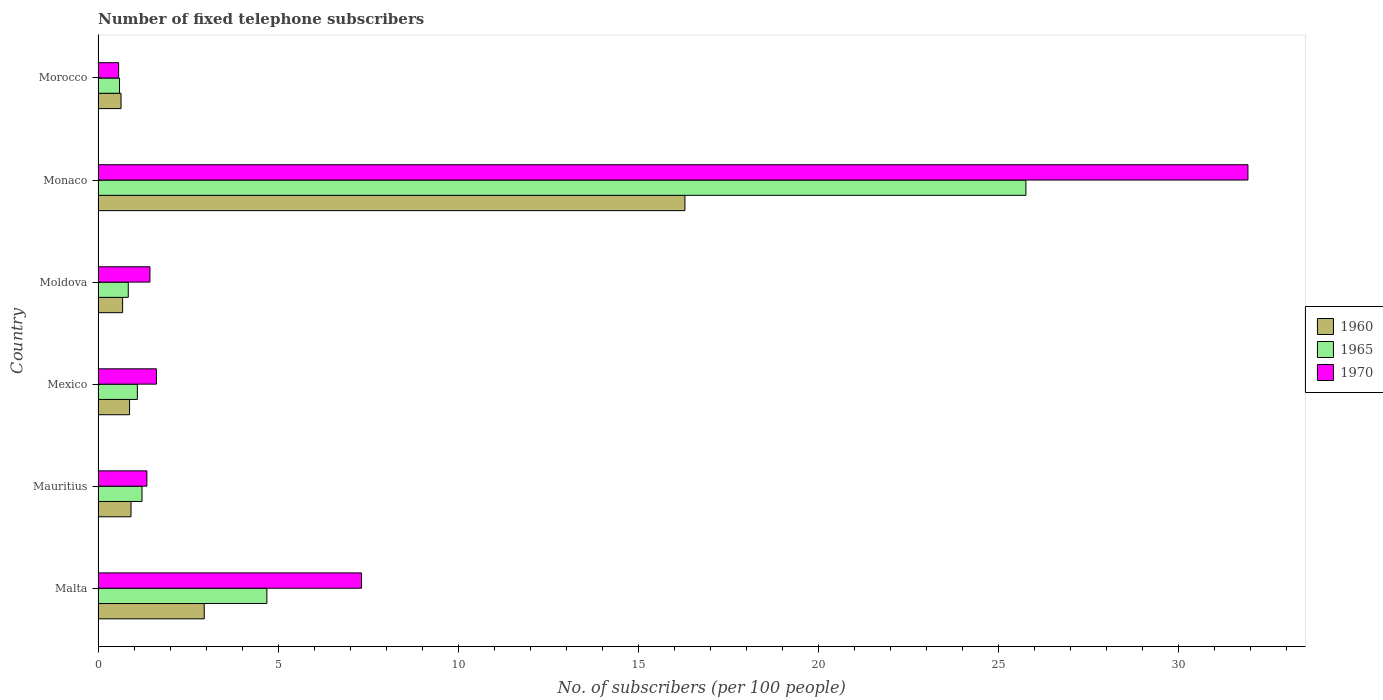How many different coloured bars are there?
Ensure brevity in your answer.  3. Are the number of bars per tick equal to the number of legend labels?
Keep it short and to the point. Yes. Are the number of bars on each tick of the Y-axis equal?
Provide a succinct answer. Yes. How many bars are there on the 4th tick from the bottom?
Your answer should be very brief. 3. What is the label of the 2nd group of bars from the top?
Offer a terse response. Monaco. In how many cases, is the number of bars for a given country not equal to the number of legend labels?
Offer a very short reply. 0. What is the number of fixed telephone subscribers in 1960 in Mauritius?
Offer a very short reply. 0.92. Across all countries, what is the maximum number of fixed telephone subscribers in 1960?
Provide a succinct answer. 16.3. Across all countries, what is the minimum number of fixed telephone subscribers in 1965?
Provide a short and direct response. 0.6. In which country was the number of fixed telephone subscribers in 1965 maximum?
Offer a terse response. Monaco. In which country was the number of fixed telephone subscribers in 1965 minimum?
Provide a succinct answer. Morocco. What is the total number of fixed telephone subscribers in 1970 in the graph?
Your response must be concise. 44.24. What is the difference between the number of fixed telephone subscribers in 1970 in Mauritius and that in Monaco?
Keep it short and to the point. -30.58. What is the difference between the number of fixed telephone subscribers in 1970 in Mauritius and the number of fixed telephone subscribers in 1965 in Morocco?
Keep it short and to the point. 0.76. What is the average number of fixed telephone subscribers in 1970 per country?
Your answer should be compact. 7.37. What is the difference between the number of fixed telephone subscribers in 1960 and number of fixed telephone subscribers in 1970 in Mauritius?
Provide a short and direct response. -0.44. What is the ratio of the number of fixed telephone subscribers in 1960 in Mauritius to that in Moldova?
Your answer should be compact. 1.34. What is the difference between the highest and the second highest number of fixed telephone subscribers in 1970?
Give a very brief answer. 24.62. What is the difference between the highest and the lowest number of fixed telephone subscribers in 1960?
Offer a terse response. 15.66. What does the 2nd bar from the top in Monaco represents?
Provide a succinct answer. 1965. How many bars are there?
Your answer should be compact. 18. Are all the bars in the graph horizontal?
Ensure brevity in your answer.  Yes. How many countries are there in the graph?
Offer a terse response. 6. Does the graph contain any zero values?
Your answer should be compact. No. How many legend labels are there?
Make the answer very short. 3. How are the legend labels stacked?
Your response must be concise. Vertical. What is the title of the graph?
Offer a terse response. Number of fixed telephone subscribers. Does "1984" appear as one of the legend labels in the graph?
Offer a very short reply. No. What is the label or title of the X-axis?
Ensure brevity in your answer.  No. of subscribers (per 100 people). What is the No. of subscribers (per 100 people) in 1960 in Malta?
Give a very brief answer. 2.95. What is the No. of subscribers (per 100 people) in 1965 in Malta?
Offer a terse response. 4.69. What is the No. of subscribers (per 100 people) of 1970 in Malta?
Give a very brief answer. 7.32. What is the No. of subscribers (per 100 people) in 1960 in Mauritius?
Provide a succinct answer. 0.92. What is the No. of subscribers (per 100 people) of 1965 in Mauritius?
Your answer should be very brief. 1.22. What is the No. of subscribers (per 100 people) of 1970 in Mauritius?
Ensure brevity in your answer.  1.36. What is the No. of subscribers (per 100 people) in 1960 in Mexico?
Offer a very short reply. 0.88. What is the No. of subscribers (per 100 people) in 1965 in Mexico?
Keep it short and to the point. 1.09. What is the No. of subscribers (per 100 people) in 1970 in Mexico?
Ensure brevity in your answer.  1.62. What is the No. of subscribers (per 100 people) of 1960 in Moldova?
Offer a very short reply. 0.68. What is the No. of subscribers (per 100 people) in 1965 in Moldova?
Ensure brevity in your answer.  0.84. What is the No. of subscribers (per 100 people) in 1970 in Moldova?
Give a very brief answer. 1.44. What is the No. of subscribers (per 100 people) of 1960 in Monaco?
Give a very brief answer. 16.3. What is the No. of subscribers (per 100 people) in 1965 in Monaco?
Make the answer very short. 25.77. What is the No. of subscribers (per 100 people) of 1970 in Monaco?
Provide a short and direct response. 31.94. What is the No. of subscribers (per 100 people) in 1960 in Morocco?
Give a very brief answer. 0.64. What is the No. of subscribers (per 100 people) of 1965 in Morocco?
Keep it short and to the point. 0.6. What is the No. of subscribers (per 100 people) in 1970 in Morocco?
Your response must be concise. 0.57. Across all countries, what is the maximum No. of subscribers (per 100 people) in 1960?
Provide a short and direct response. 16.3. Across all countries, what is the maximum No. of subscribers (per 100 people) of 1965?
Your answer should be compact. 25.77. Across all countries, what is the maximum No. of subscribers (per 100 people) of 1970?
Provide a short and direct response. 31.94. Across all countries, what is the minimum No. of subscribers (per 100 people) in 1960?
Your response must be concise. 0.64. Across all countries, what is the minimum No. of subscribers (per 100 people) in 1965?
Provide a succinct answer. 0.6. Across all countries, what is the minimum No. of subscribers (per 100 people) in 1970?
Provide a short and direct response. 0.57. What is the total No. of subscribers (per 100 people) in 1960 in the graph?
Keep it short and to the point. 22.36. What is the total No. of subscribers (per 100 people) of 1965 in the graph?
Provide a succinct answer. 34.21. What is the total No. of subscribers (per 100 people) of 1970 in the graph?
Provide a succinct answer. 44.24. What is the difference between the No. of subscribers (per 100 people) of 1960 in Malta and that in Mauritius?
Make the answer very short. 2.03. What is the difference between the No. of subscribers (per 100 people) of 1965 in Malta and that in Mauritius?
Keep it short and to the point. 3.47. What is the difference between the No. of subscribers (per 100 people) of 1970 in Malta and that in Mauritius?
Make the answer very short. 5.96. What is the difference between the No. of subscribers (per 100 people) in 1960 in Malta and that in Mexico?
Provide a short and direct response. 2.07. What is the difference between the No. of subscribers (per 100 people) of 1965 in Malta and that in Mexico?
Keep it short and to the point. 3.6. What is the difference between the No. of subscribers (per 100 people) of 1970 in Malta and that in Mexico?
Your answer should be very brief. 5.7. What is the difference between the No. of subscribers (per 100 people) of 1960 in Malta and that in Moldova?
Keep it short and to the point. 2.27. What is the difference between the No. of subscribers (per 100 people) in 1965 in Malta and that in Moldova?
Provide a short and direct response. 3.85. What is the difference between the No. of subscribers (per 100 people) in 1970 in Malta and that in Moldova?
Your answer should be very brief. 5.88. What is the difference between the No. of subscribers (per 100 people) of 1960 in Malta and that in Monaco?
Provide a short and direct response. -13.35. What is the difference between the No. of subscribers (per 100 people) of 1965 in Malta and that in Monaco?
Offer a very short reply. -21.08. What is the difference between the No. of subscribers (per 100 people) of 1970 in Malta and that in Monaco?
Keep it short and to the point. -24.62. What is the difference between the No. of subscribers (per 100 people) in 1960 in Malta and that in Morocco?
Make the answer very short. 2.31. What is the difference between the No. of subscribers (per 100 people) in 1965 in Malta and that in Morocco?
Your answer should be very brief. 4.09. What is the difference between the No. of subscribers (per 100 people) of 1970 in Malta and that in Morocco?
Your answer should be compact. 6.75. What is the difference between the No. of subscribers (per 100 people) of 1960 in Mauritius and that in Mexico?
Your answer should be compact. 0.04. What is the difference between the No. of subscribers (per 100 people) in 1965 in Mauritius and that in Mexico?
Your response must be concise. 0.13. What is the difference between the No. of subscribers (per 100 people) of 1970 in Mauritius and that in Mexico?
Ensure brevity in your answer.  -0.26. What is the difference between the No. of subscribers (per 100 people) of 1960 in Mauritius and that in Moldova?
Your answer should be compact. 0.23. What is the difference between the No. of subscribers (per 100 people) of 1965 in Mauritius and that in Moldova?
Provide a succinct answer. 0.38. What is the difference between the No. of subscribers (per 100 people) of 1970 in Mauritius and that in Moldova?
Provide a succinct answer. -0.08. What is the difference between the No. of subscribers (per 100 people) of 1960 in Mauritius and that in Monaco?
Your answer should be very brief. -15.38. What is the difference between the No. of subscribers (per 100 people) in 1965 in Mauritius and that in Monaco?
Ensure brevity in your answer.  -24.55. What is the difference between the No. of subscribers (per 100 people) in 1970 in Mauritius and that in Monaco?
Your answer should be compact. -30.58. What is the difference between the No. of subscribers (per 100 people) of 1960 in Mauritius and that in Morocco?
Give a very brief answer. 0.28. What is the difference between the No. of subscribers (per 100 people) in 1965 in Mauritius and that in Morocco?
Your response must be concise. 0.63. What is the difference between the No. of subscribers (per 100 people) in 1970 in Mauritius and that in Morocco?
Keep it short and to the point. 0.78. What is the difference between the No. of subscribers (per 100 people) in 1960 in Mexico and that in Moldova?
Your answer should be compact. 0.19. What is the difference between the No. of subscribers (per 100 people) in 1965 in Mexico and that in Moldova?
Provide a succinct answer. 0.25. What is the difference between the No. of subscribers (per 100 people) of 1970 in Mexico and that in Moldova?
Give a very brief answer. 0.18. What is the difference between the No. of subscribers (per 100 people) in 1960 in Mexico and that in Monaco?
Your answer should be very brief. -15.42. What is the difference between the No. of subscribers (per 100 people) in 1965 in Mexico and that in Monaco?
Provide a short and direct response. -24.68. What is the difference between the No. of subscribers (per 100 people) in 1970 in Mexico and that in Monaco?
Your response must be concise. -30.32. What is the difference between the No. of subscribers (per 100 people) in 1960 in Mexico and that in Morocco?
Your answer should be compact. 0.24. What is the difference between the No. of subscribers (per 100 people) of 1965 in Mexico and that in Morocco?
Offer a very short reply. 0.5. What is the difference between the No. of subscribers (per 100 people) of 1970 in Mexico and that in Morocco?
Your response must be concise. 1.05. What is the difference between the No. of subscribers (per 100 people) of 1960 in Moldova and that in Monaco?
Offer a terse response. -15.62. What is the difference between the No. of subscribers (per 100 people) in 1965 in Moldova and that in Monaco?
Offer a very short reply. -24.93. What is the difference between the No. of subscribers (per 100 people) in 1970 in Moldova and that in Monaco?
Your answer should be compact. -30.5. What is the difference between the No. of subscribers (per 100 people) of 1960 in Moldova and that in Morocco?
Your answer should be compact. 0.04. What is the difference between the No. of subscribers (per 100 people) in 1965 in Moldova and that in Morocco?
Offer a terse response. 0.24. What is the difference between the No. of subscribers (per 100 people) in 1970 in Moldova and that in Morocco?
Your answer should be compact. 0.87. What is the difference between the No. of subscribers (per 100 people) of 1960 in Monaco and that in Morocco?
Offer a terse response. 15.66. What is the difference between the No. of subscribers (per 100 people) of 1965 in Monaco and that in Morocco?
Provide a short and direct response. 25.17. What is the difference between the No. of subscribers (per 100 people) in 1970 in Monaco and that in Morocco?
Give a very brief answer. 31.36. What is the difference between the No. of subscribers (per 100 people) in 1960 in Malta and the No. of subscribers (per 100 people) in 1965 in Mauritius?
Offer a terse response. 1.73. What is the difference between the No. of subscribers (per 100 people) in 1960 in Malta and the No. of subscribers (per 100 people) in 1970 in Mauritius?
Provide a succinct answer. 1.59. What is the difference between the No. of subscribers (per 100 people) of 1965 in Malta and the No. of subscribers (per 100 people) of 1970 in Mauritius?
Your response must be concise. 3.33. What is the difference between the No. of subscribers (per 100 people) in 1960 in Malta and the No. of subscribers (per 100 people) in 1965 in Mexico?
Offer a terse response. 1.86. What is the difference between the No. of subscribers (per 100 people) of 1960 in Malta and the No. of subscribers (per 100 people) of 1970 in Mexico?
Provide a short and direct response. 1.33. What is the difference between the No. of subscribers (per 100 people) of 1965 in Malta and the No. of subscribers (per 100 people) of 1970 in Mexico?
Provide a succinct answer. 3.07. What is the difference between the No. of subscribers (per 100 people) in 1960 in Malta and the No. of subscribers (per 100 people) in 1965 in Moldova?
Your answer should be compact. 2.11. What is the difference between the No. of subscribers (per 100 people) of 1960 in Malta and the No. of subscribers (per 100 people) of 1970 in Moldova?
Give a very brief answer. 1.51. What is the difference between the No. of subscribers (per 100 people) in 1965 in Malta and the No. of subscribers (per 100 people) in 1970 in Moldova?
Offer a terse response. 3.25. What is the difference between the No. of subscribers (per 100 people) in 1960 in Malta and the No. of subscribers (per 100 people) in 1965 in Monaco?
Your answer should be compact. -22.82. What is the difference between the No. of subscribers (per 100 people) in 1960 in Malta and the No. of subscribers (per 100 people) in 1970 in Monaco?
Your answer should be very brief. -28.99. What is the difference between the No. of subscribers (per 100 people) of 1965 in Malta and the No. of subscribers (per 100 people) of 1970 in Monaco?
Keep it short and to the point. -27.25. What is the difference between the No. of subscribers (per 100 people) of 1960 in Malta and the No. of subscribers (per 100 people) of 1965 in Morocco?
Offer a very short reply. 2.35. What is the difference between the No. of subscribers (per 100 people) in 1960 in Malta and the No. of subscribers (per 100 people) in 1970 in Morocco?
Offer a terse response. 2.38. What is the difference between the No. of subscribers (per 100 people) in 1965 in Malta and the No. of subscribers (per 100 people) in 1970 in Morocco?
Provide a succinct answer. 4.12. What is the difference between the No. of subscribers (per 100 people) of 1960 in Mauritius and the No. of subscribers (per 100 people) of 1965 in Mexico?
Ensure brevity in your answer.  -0.18. What is the difference between the No. of subscribers (per 100 people) in 1960 in Mauritius and the No. of subscribers (per 100 people) in 1970 in Mexico?
Ensure brevity in your answer.  -0.7. What is the difference between the No. of subscribers (per 100 people) in 1965 in Mauritius and the No. of subscribers (per 100 people) in 1970 in Mexico?
Ensure brevity in your answer.  -0.4. What is the difference between the No. of subscribers (per 100 people) in 1960 in Mauritius and the No. of subscribers (per 100 people) in 1965 in Moldova?
Offer a terse response. 0.08. What is the difference between the No. of subscribers (per 100 people) in 1960 in Mauritius and the No. of subscribers (per 100 people) in 1970 in Moldova?
Make the answer very short. -0.52. What is the difference between the No. of subscribers (per 100 people) of 1965 in Mauritius and the No. of subscribers (per 100 people) of 1970 in Moldova?
Provide a short and direct response. -0.22. What is the difference between the No. of subscribers (per 100 people) of 1960 in Mauritius and the No. of subscribers (per 100 people) of 1965 in Monaco?
Offer a terse response. -24.85. What is the difference between the No. of subscribers (per 100 people) of 1960 in Mauritius and the No. of subscribers (per 100 people) of 1970 in Monaco?
Offer a very short reply. -31.02. What is the difference between the No. of subscribers (per 100 people) of 1965 in Mauritius and the No. of subscribers (per 100 people) of 1970 in Monaco?
Offer a terse response. -30.72. What is the difference between the No. of subscribers (per 100 people) of 1960 in Mauritius and the No. of subscribers (per 100 people) of 1965 in Morocco?
Make the answer very short. 0.32. What is the difference between the No. of subscribers (per 100 people) of 1960 in Mauritius and the No. of subscribers (per 100 people) of 1970 in Morocco?
Offer a terse response. 0.34. What is the difference between the No. of subscribers (per 100 people) in 1965 in Mauritius and the No. of subscribers (per 100 people) in 1970 in Morocco?
Make the answer very short. 0.65. What is the difference between the No. of subscribers (per 100 people) in 1960 in Mexico and the No. of subscribers (per 100 people) in 1965 in Moldova?
Ensure brevity in your answer.  0.04. What is the difference between the No. of subscribers (per 100 people) in 1960 in Mexico and the No. of subscribers (per 100 people) in 1970 in Moldova?
Provide a short and direct response. -0.57. What is the difference between the No. of subscribers (per 100 people) of 1965 in Mexico and the No. of subscribers (per 100 people) of 1970 in Moldova?
Ensure brevity in your answer.  -0.35. What is the difference between the No. of subscribers (per 100 people) in 1960 in Mexico and the No. of subscribers (per 100 people) in 1965 in Monaco?
Offer a terse response. -24.89. What is the difference between the No. of subscribers (per 100 people) in 1960 in Mexico and the No. of subscribers (per 100 people) in 1970 in Monaco?
Give a very brief answer. -31.06. What is the difference between the No. of subscribers (per 100 people) in 1965 in Mexico and the No. of subscribers (per 100 people) in 1970 in Monaco?
Your answer should be compact. -30.84. What is the difference between the No. of subscribers (per 100 people) of 1960 in Mexico and the No. of subscribers (per 100 people) of 1965 in Morocco?
Provide a succinct answer. 0.28. What is the difference between the No. of subscribers (per 100 people) of 1960 in Mexico and the No. of subscribers (per 100 people) of 1970 in Morocco?
Provide a succinct answer. 0.3. What is the difference between the No. of subscribers (per 100 people) in 1965 in Mexico and the No. of subscribers (per 100 people) in 1970 in Morocco?
Keep it short and to the point. 0.52. What is the difference between the No. of subscribers (per 100 people) of 1960 in Moldova and the No. of subscribers (per 100 people) of 1965 in Monaco?
Provide a succinct answer. -25.09. What is the difference between the No. of subscribers (per 100 people) of 1960 in Moldova and the No. of subscribers (per 100 people) of 1970 in Monaco?
Make the answer very short. -31.25. What is the difference between the No. of subscribers (per 100 people) of 1965 in Moldova and the No. of subscribers (per 100 people) of 1970 in Monaco?
Your answer should be compact. -31.1. What is the difference between the No. of subscribers (per 100 people) of 1960 in Moldova and the No. of subscribers (per 100 people) of 1965 in Morocco?
Provide a short and direct response. 0.09. What is the difference between the No. of subscribers (per 100 people) in 1960 in Moldova and the No. of subscribers (per 100 people) in 1970 in Morocco?
Ensure brevity in your answer.  0.11. What is the difference between the No. of subscribers (per 100 people) of 1965 in Moldova and the No. of subscribers (per 100 people) of 1970 in Morocco?
Your response must be concise. 0.27. What is the difference between the No. of subscribers (per 100 people) in 1960 in Monaco and the No. of subscribers (per 100 people) in 1965 in Morocco?
Make the answer very short. 15.7. What is the difference between the No. of subscribers (per 100 people) in 1960 in Monaco and the No. of subscribers (per 100 people) in 1970 in Morocco?
Ensure brevity in your answer.  15.73. What is the difference between the No. of subscribers (per 100 people) in 1965 in Monaco and the No. of subscribers (per 100 people) in 1970 in Morocco?
Your answer should be compact. 25.2. What is the average No. of subscribers (per 100 people) in 1960 per country?
Give a very brief answer. 3.73. What is the average No. of subscribers (per 100 people) of 1965 per country?
Offer a very short reply. 5.7. What is the average No. of subscribers (per 100 people) in 1970 per country?
Your response must be concise. 7.37. What is the difference between the No. of subscribers (per 100 people) of 1960 and No. of subscribers (per 100 people) of 1965 in Malta?
Provide a succinct answer. -1.74. What is the difference between the No. of subscribers (per 100 people) of 1960 and No. of subscribers (per 100 people) of 1970 in Malta?
Give a very brief answer. -4.37. What is the difference between the No. of subscribers (per 100 people) in 1965 and No. of subscribers (per 100 people) in 1970 in Malta?
Your answer should be compact. -2.63. What is the difference between the No. of subscribers (per 100 people) of 1960 and No. of subscribers (per 100 people) of 1965 in Mauritius?
Provide a short and direct response. -0.31. What is the difference between the No. of subscribers (per 100 people) in 1960 and No. of subscribers (per 100 people) in 1970 in Mauritius?
Offer a terse response. -0.44. What is the difference between the No. of subscribers (per 100 people) of 1965 and No. of subscribers (per 100 people) of 1970 in Mauritius?
Your response must be concise. -0.14. What is the difference between the No. of subscribers (per 100 people) in 1960 and No. of subscribers (per 100 people) in 1965 in Mexico?
Keep it short and to the point. -0.22. What is the difference between the No. of subscribers (per 100 people) of 1960 and No. of subscribers (per 100 people) of 1970 in Mexico?
Offer a terse response. -0.75. What is the difference between the No. of subscribers (per 100 people) of 1965 and No. of subscribers (per 100 people) of 1970 in Mexico?
Make the answer very short. -0.53. What is the difference between the No. of subscribers (per 100 people) in 1960 and No. of subscribers (per 100 people) in 1965 in Moldova?
Your answer should be very brief. -0.16. What is the difference between the No. of subscribers (per 100 people) of 1960 and No. of subscribers (per 100 people) of 1970 in Moldova?
Keep it short and to the point. -0.76. What is the difference between the No. of subscribers (per 100 people) in 1965 and No. of subscribers (per 100 people) in 1970 in Moldova?
Provide a short and direct response. -0.6. What is the difference between the No. of subscribers (per 100 people) in 1960 and No. of subscribers (per 100 people) in 1965 in Monaco?
Keep it short and to the point. -9.47. What is the difference between the No. of subscribers (per 100 people) of 1960 and No. of subscribers (per 100 people) of 1970 in Monaco?
Keep it short and to the point. -15.64. What is the difference between the No. of subscribers (per 100 people) in 1965 and No. of subscribers (per 100 people) in 1970 in Monaco?
Provide a succinct answer. -6.17. What is the difference between the No. of subscribers (per 100 people) of 1960 and No. of subscribers (per 100 people) of 1965 in Morocco?
Your response must be concise. 0.04. What is the difference between the No. of subscribers (per 100 people) in 1960 and No. of subscribers (per 100 people) in 1970 in Morocco?
Offer a very short reply. 0.07. What is the difference between the No. of subscribers (per 100 people) in 1965 and No. of subscribers (per 100 people) in 1970 in Morocco?
Your answer should be very brief. 0.02. What is the ratio of the No. of subscribers (per 100 people) in 1960 in Malta to that in Mauritius?
Offer a very short reply. 3.22. What is the ratio of the No. of subscribers (per 100 people) in 1965 in Malta to that in Mauritius?
Ensure brevity in your answer.  3.84. What is the ratio of the No. of subscribers (per 100 people) of 1970 in Malta to that in Mauritius?
Make the answer very short. 5.39. What is the ratio of the No. of subscribers (per 100 people) of 1960 in Malta to that in Mexico?
Offer a terse response. 3.37. What is the ratio of the No. of subscribers (per 100 people) in 1965 in Malta to that in Mexico?
Provide a short and direct response. 4.3. What is the ratio of the No. of subscribers (per 100 people) of 1970 in Malta to that in Mexico?
Provide a short and direct response. 4.52. What is the ratio of the No. of subscribers (per 100 people) of 1960 in Malta to that in Moldova?
Offer a terse response. 4.32. What is the ratio of the No. of subscribers (per 100 people) of 1965 in Malta to that in Moldova?
Ensure brevity in your answer.  5.59. What is the ratio of the No. of subscribers (per 100 people) in 1970 in Malta to that in Moldova?
Ensure brevity in your answer.  5.08. What is the ratio of the No. of subscribers (per 100 people) in 1960 in Malta to that in Monaco?
Offer a very short reply. 0.18. What is the ratio of the No. of subscribers (per 100 people) of 1965 in Malta to that in Monaco?
Your response must be concise. 0.18. What is the ratio of the No. of subscribers (per 100 people) of 1970 in Malta to that in Monaco?
Your response must be concise. 0.23. What is the ratio of the No. of subscribers (per 100 people) in 1960 in Malta to that in Morocco?
Keep it short and to the point. 4.62. What is the ratio of the No. of subscribers (per 100 people) in 1965 in Malta to that in Morocco?
Offer a terse response. 7.87. What is the ratio of the No. of subscribers (per 100 people) of 1970 in Malta to that in Morocco?
Your response must be concise. 12.8. What is the ratio of the No. of subscribers (per 100 people) in 1960 in Mauritius to that in Mexico?
Your answer should be compact. 1.05. What is the ratio of the No. of subscribers (per 100 people) of 1965 in Mauritius to that in Mexico?
Keep it short and to the point. 1.12. What is the ratio of the No. of subscribers (per 100 people) of 1970 in Mauritius to that in Mexico?
Offer a very short reply. 0.84. What is the ratio of the No. of subscribers (per 100 people) in 1960 in Mauritius to that in Moldova?
Your answer should be very brief. 1.34. What is the ratio of the No. of subscribers (per 100 people) of 1965 in Mauritius to that in Moldova?
Make the answer very short. 1.45. What is the ratio of the No. of subscribers (per 100 people) of 1970 in Mauritius to that in Moldova?
Make the answer very short. 0.94. What is the ratio of the No. of subscribers (per 100 people) of 1960 in Mauritius to that in Monaco?
Provide a succinct answer. 0.06. What is the ratio of the No. of subscribers (per 100 people) in 1965 in Mauritius to that in Monaco?
Keep it short and to the point. 0.05. What is the ratio of the No. of subscribers (per 100 people) of 1970 in Mauritius to that in Monaco?
Keep it short and to the point. 0.04. What is the ratio of the No. of subscribers (per 100 people) of 1960 in Mauritius to that in Morocco?
Ensure brevity in your answer.  1.44. What is the ratio of the No. of subscribers (per 100 people) in 1965 in Mauritius to that in Morocco?
Give a very brief answer. 2.05. What is the ratio of the No. of subscribers (per 100 people) in 1970 in Mauritius to that in Morocco?
Ensure brevity in your answer.  2.37. What is the ratio of the No. of subscribers (per 100 people) of 1960 in Mexico to that in Moldova?
Give a very brief answer. 1.28. What is the ratio of the No. of subscribers (per 100 people) in 1965 in Mexico to that in Moldova?
Offer a very short reply. 1.3. What is the ratio of the No. of subscribers (per 100 people) in 1970 in Mexico to that in Moldova?
Your answer should be very brief. 1.12. What is the ratio of the No. of subscribers (per 100 people) of 1960 in Mexico to that in Monaco?
Your answer should be compact. 0.05. What is the ratio of the No. of subscribers (per 100 people) of 1965 in Mexico to that in Monaco?
Offer a terse response. 0.04. What is the ratio of the No. of subscribers (per 100 people) in 1970 in Mexico to that in Monaco?
Your response must be concise. 0.05. What is the ratio of the No. of subscribers (per 100 people) of 1960 in Mexico to that in Morocco?
Your response must be concise. 1.37. What is the ratio of the No. of subscribers (per 100 people) of 1965 in Mexico to that in Morocco?
Make the answer very short. 1.83. What is the ratio of the No. of subscribers (per 100 people) in 1970 in Mexico to that in Morocco?
Offer a very short reply. 2.83. What is the ratio of the No. of subscribers (per 100 people) of 1960 in Moldova to that in Monaco?
Your response must be concise. 0.04. What is the ratio of the No. of subscribers (per 100 people) in 1965 in Moldova to that in Monaco?
Keep it short and to the point. 0.03. What is the ratio of the No. of subscribers (per 100 people) in 1970 in Moldova to that in Monaco?
Your answer should be very brief. 0.05. What is the ratio of the No. of subscribers (per 100 people) of 1960 in Moldova to that in Morocco?
Offer a very short reply. 1.07. What is the ratio of the No. of subscribers (per 100 people) in 1965 in Moldova to that in Morocco?
Offer a terse response. 1.41. What is the ratio of the No. of subscribers (per 100 people) of 1970 in Moldova to that in Morocco?
Provide a short and direct response. 2.52. What is the ratio of the No. of subscribers (per 100 people) of 1960 in Monaco to that in Morocco?
Offer a very short reply. 25.54. What is the ratio of the No. of subscribers (per 100 people) in 1965 in Monaco to that in Morocco?
Make the answer very short. 43.23. What is the ratio of the No. of subscribers (per 100 people) in 1970 in Monaco to that in Morocco?
Provide a succinct answer. 55.86. What is the difference between the highest and the second highest No. of subscribers (per 100 people) of 1960?
Give a very brief answer. 13.35. What is the difference between the highest and the second highest No. of subscribers (per 100 people) in 1965?
Provide a succinct answer. 21.08. What is the difference between the highest and the second highest No. of subscribers (per 100 people) of 1970?
Your response must be concise. 24.62. What is the difference between the highest and the lowest No. of subscribers (per 100 people) of 1960?
Give a very brief answer. 15.66. What is the difference between the highest and the lowest No. of subscribers (per 100 people) of 1965?
Provide a succinct answer. 25.17. What is the difference between the highest and the lowest No. of subscribers (per 100 people) in 1970?
Your answer should be compact. 31.36. 